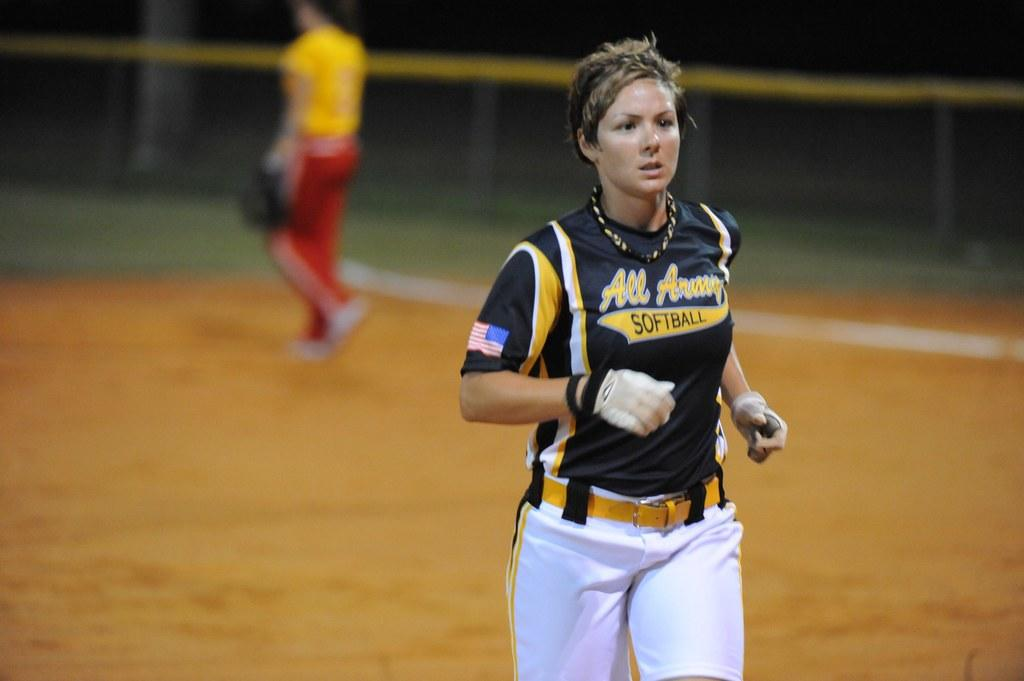<image>
Render a clear and concise summary of the photo. A woman wearing an All Army Softball shirt on the field. 